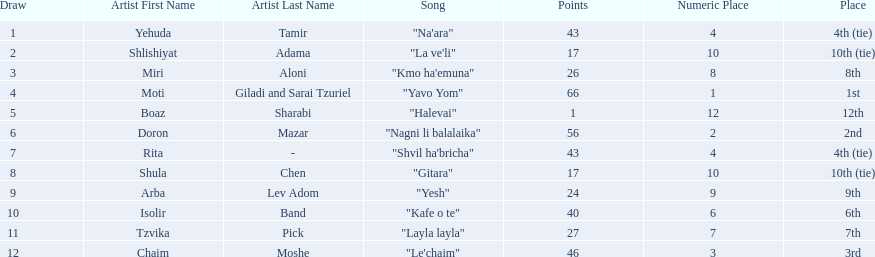How many artists are there? Yehuda Tamir, Shlishiyat Adama, Miri Aloni, Moti Giladi and Sarai Tzuriel, Boaz Sharabi, Doron Mazar, Rita, Shula Chen, Arba Lev Adom, Isolir Band, Tzvika Pick, Chaim Moshe. What is the least amount of points awarded? 1. Who was the artist awarded those points? Boaz Sharabi. 